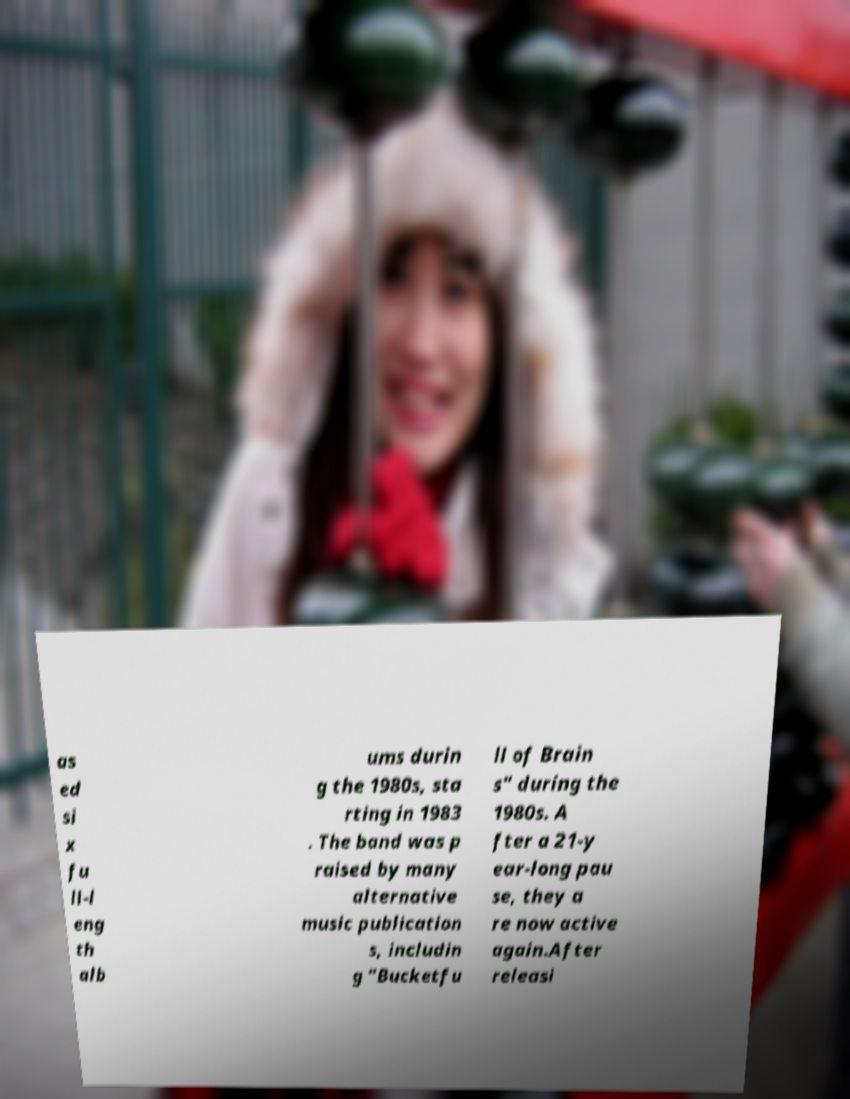For documentation purposes, I need the text within this image transcribed. Could you provide that? as ed si x fu ll-l eng th alb ums durin g the 1980s, sta rting in 1983 . The band was p raised by many alternative music publication s, includin g "Bucketfu ll of Brain s" during the 1980s. A fter a 21-y ear-long pau se, they a re now active again.After releasi 